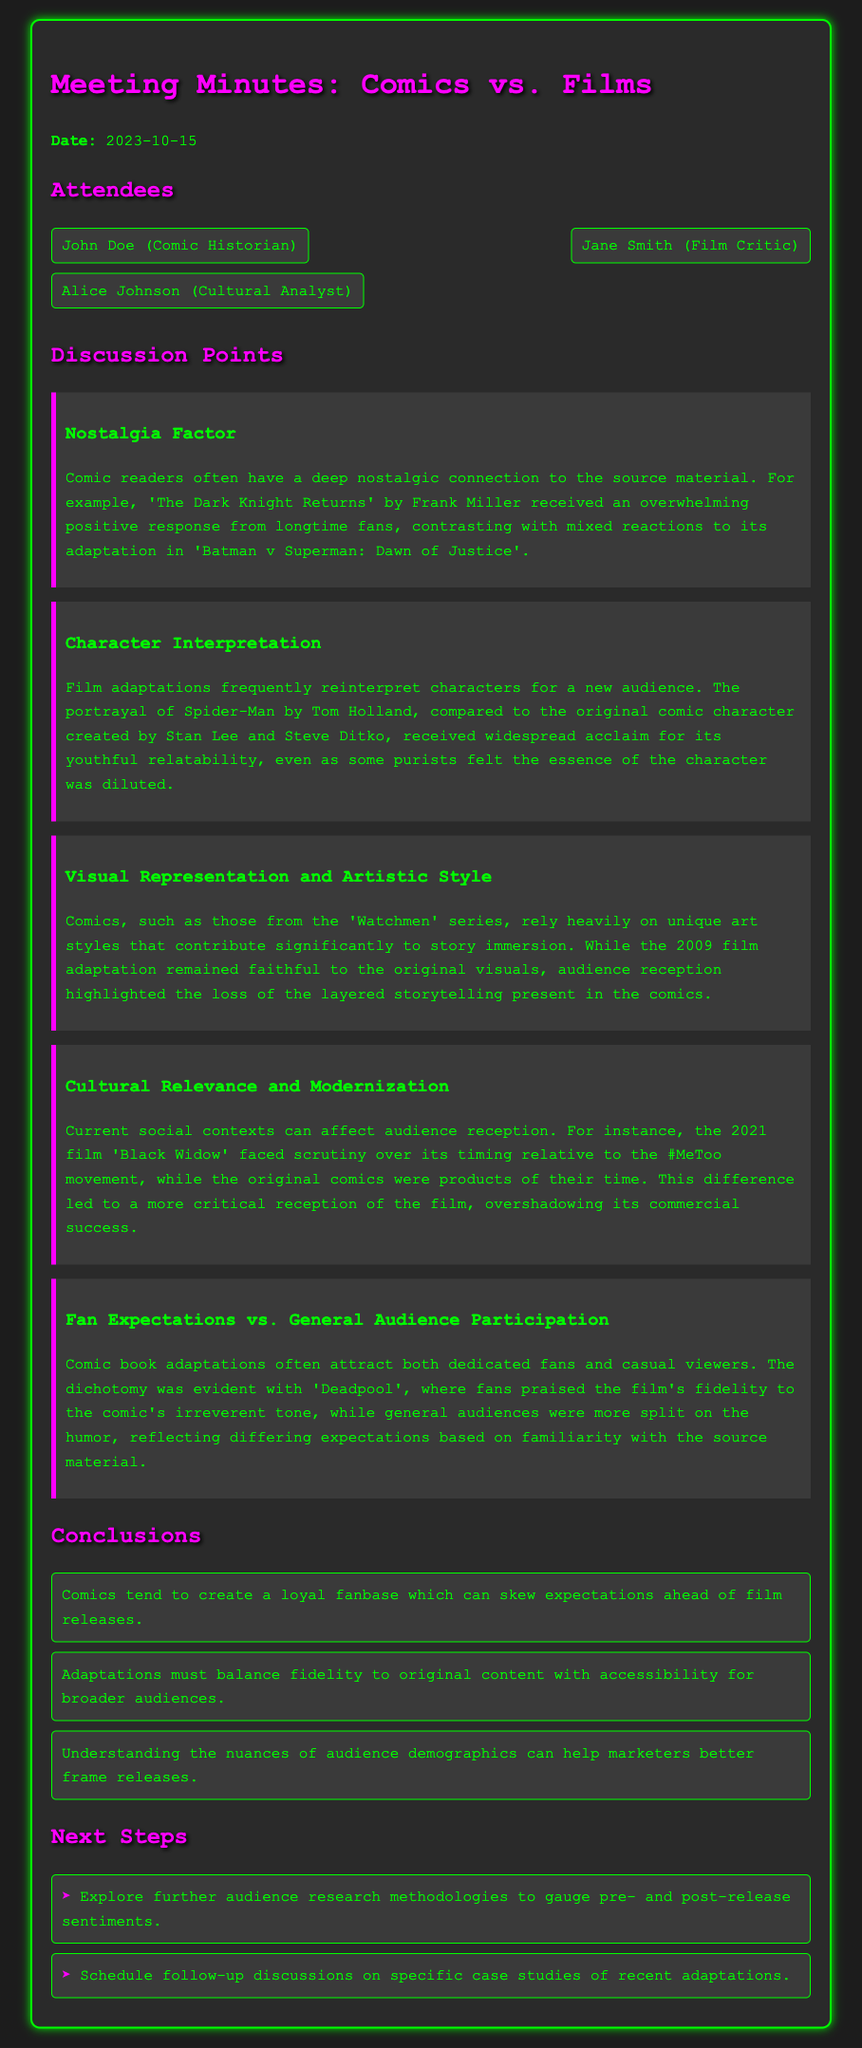what is the date of the meeting? The date of the meeting is explicitly stated in the document.
Answer: 2023-10-15 who are the attendees? The attendees are listed in the document under the section "Attendees".
Answer: John Doe, Jane Smith, Alice Johnson what is one discussion point mentioned? The discussion points are detailed in the document, and a few examples can be cited.
Answer: Nostalgia Factor who is the comic historian present at the meeting? The document specifies the roles of attendees, identifying the comic historian.
Answer: John Doe which film faced scrutiny over its timing relative to the #MeToo movement? This information is derived from the discussion points regarding cultural relevance and modernization.
Answer: Black Widow how did audiences react to the adaptation of 'The Dark Knight Returns'? The document describes audience reactions in comparison to the film adaptation.
Answer: Mixed reactions what is a conclusion drawn from the meeting? Several conclusions are listed in the document, encapsulating key insights from discussions.
Answer: Comics tend to create a loyal fanbase which can skew expectations ahead of film releases what are the next steps mentioned? The document outlines future actions that the attendees plan to take after the meeting.
Answer: Explore further audience research methodologies which character's portrayal was compared between the films and the comics? The document notes significant comparisons between adaptations and the original comic characters.
Answer: Spider-Man 